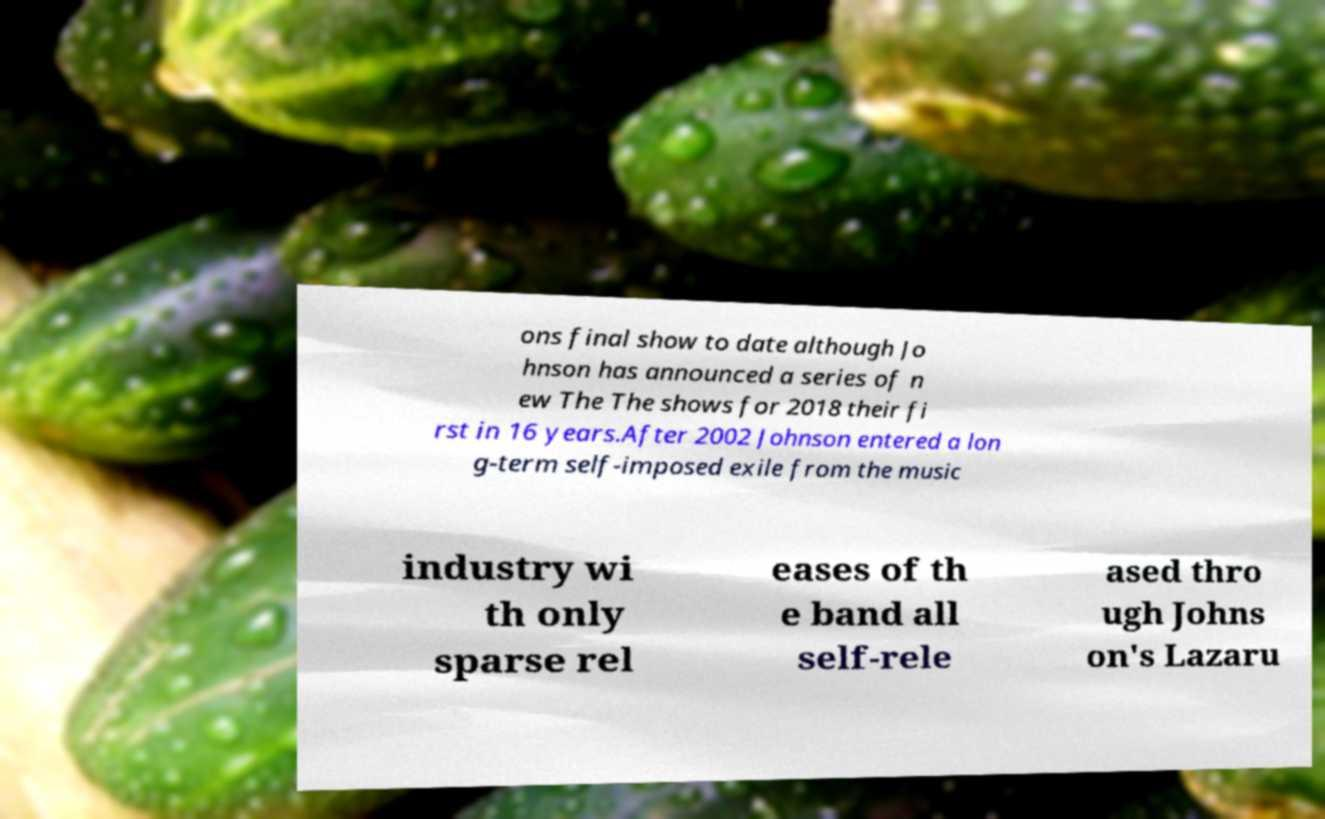Please read and relay the text visible in this image. What does it say? ons final show to date although Jo hnson has announced a series of n ew The The shows for 2018 their fi rst in 16 years.After 2002 Johnson entered a lon g-term self-imposed exile from the music industry wi th only sparse rel eases of th e band all self-rele ased thro ugh Johns on's Lazaru 